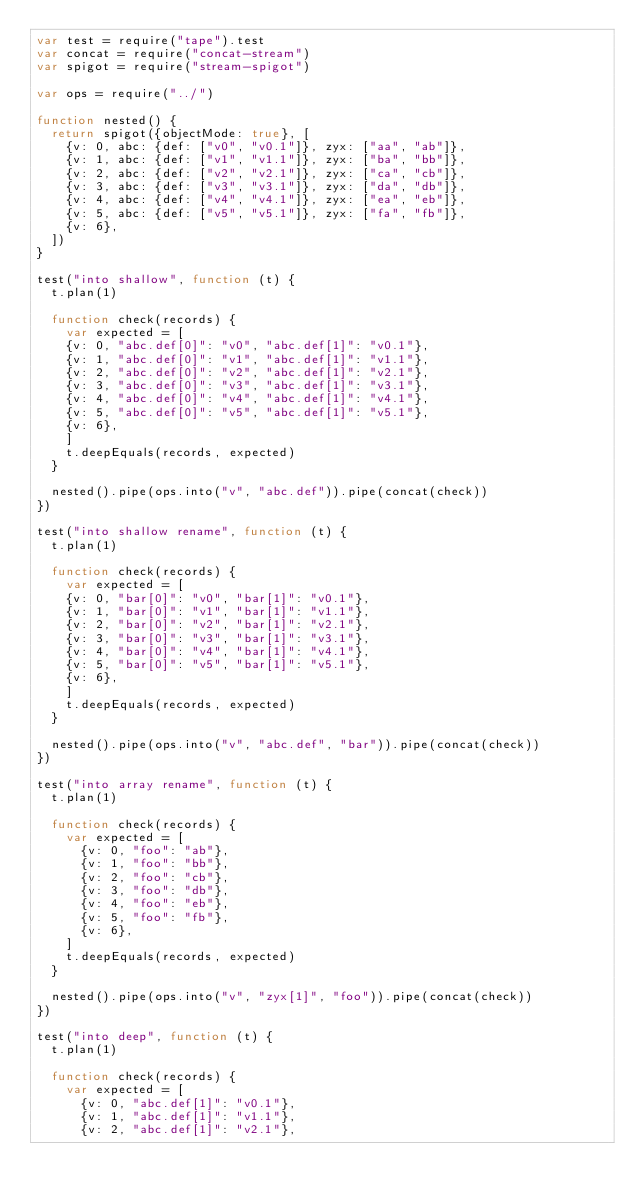Convert code to text. <code><loc_0><loc_0><loc_500><loc_500><_JavaScript_>var test = require("tape").test
var concat = require("concat-stream")
var spigot = require("stream-spigot")

var ops = require("../")

function nested() {
  return spigot({objectMode: true}, [
    {v: 0, abc: {def: ["v0", "v0.1"]}, zyx: ["aa", "ab"]},
    {v: 1, abc: {def: ["v1", "v1.1"]}, zyx: ["ba", "bb"]},
    {v: 2, abc: {def: ["v2", "v2.1"]}, zyx: ["ca", "cb"]},
    {v: 3, abc: {def: ["v3", "v3.1"]}, zyx: ["da", "db"]},
    {v: 4, abc: {def: ["v4", "v4.1"]}, zyx: ["ea", "eb"]},
    {v: 5, abc: {def: ["v5", "v5.1"]}, zyx: ["fa", "fb"]},
    {v: 6},
  ])
}

test("into shallow", function (t) {
  t.plan(1)

  function check(records) {
    var expected = [
    {v: 0, "abc.def[0]": "v0", "abc.def[1]": "v0.1"},
    {v: 1, "abc.def[0]": "v1", "abc.def[1]": "v1.1"},
    {v: 2, "abc.def[0]": "v2", "abc.def[1]": "v2.1"},
    {v: 3, "abc.def[0]": "v3", "abc.def[1]": "v3.1"},
    {v: 4, "abc.def[0]": "v4", "abc.def[1]": "v4.1"},
    {v: 5, "abc.def[0]": "v5", "abc.def[1]": "v5.1"},
    {v: 6},
    ]
    t.deepEquals(records, expected)
  }

  nested().pipe(ops.into("v", "abc.def")).pipe(concat(check))
})

test("into shallow rename", function (t) {
  t.plan(1)

  function check(records) {
    var expected = [
    {v: 0, "bar[0]": "v0", "bar[1]": "v0.1"},
    {v: 1, "bar[0]": "v1", "bar[1]": "v1.1"},
    {v: 2, "bar[0]": "v2", "bar[1]": "v2.1"},
    {v: 3, "bar[0]": "v3", "bar[1]": "v3.1"},
    {v: 4, "bar[0]": "v4", "bar[1]": "v4.1"},
    {v: 5, "bar[0]": "v5", "bar[1]": "v5.1"},
    {v: 6},
    ]
    t.deepEquals(records, expected)
  }

  nested().pipe(ops.into("v", "abc.def", "bar")).pipe(concat(check))
})

test("into array rename", function (t) {
  t.plan(1)

  function check(records) {
    var expected = [
      {v: 0, "foo": "ab"},
      {v: 1, "foo": "bb"},
      {v: 2, "foo": "cb"},
      {v: 3, "foo": "db"},
      {v: 4, "foo": "eb"},
      {v: 5, "foo": "fb"},
      {v: 6},
    ]
    t.deepEquals(records, expected)
  }

  nested().pipe(ops.into("v", "zyx[1]", "foo")).pipe(concat(check))
})

test("into deep", function (t) {
  t.plan(1)

  function check(records) {
    var expected = [
      {v: 0, "abc.def[1]": "v0.1"},
      {v: 1, "abc.def[1]": "v1.1"},
      {v: 2, "abc.def[1]": "v2.1"},</code> 